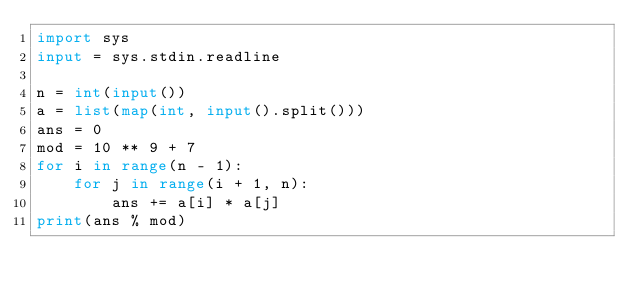Convert code to text. <code><loc_0><loc_0><loc_500><loc_500><_Python_>import sys
input = sys.stdin.readline

n = int(input())
a = list(map(int, input().split()))
ans = 0
mod = 10 ** 9 + 7
for i in range(n - 1):
    for j in range(i + 1, n):
        ans += a[i] * a[j]
print(ans % mod)
</code> 